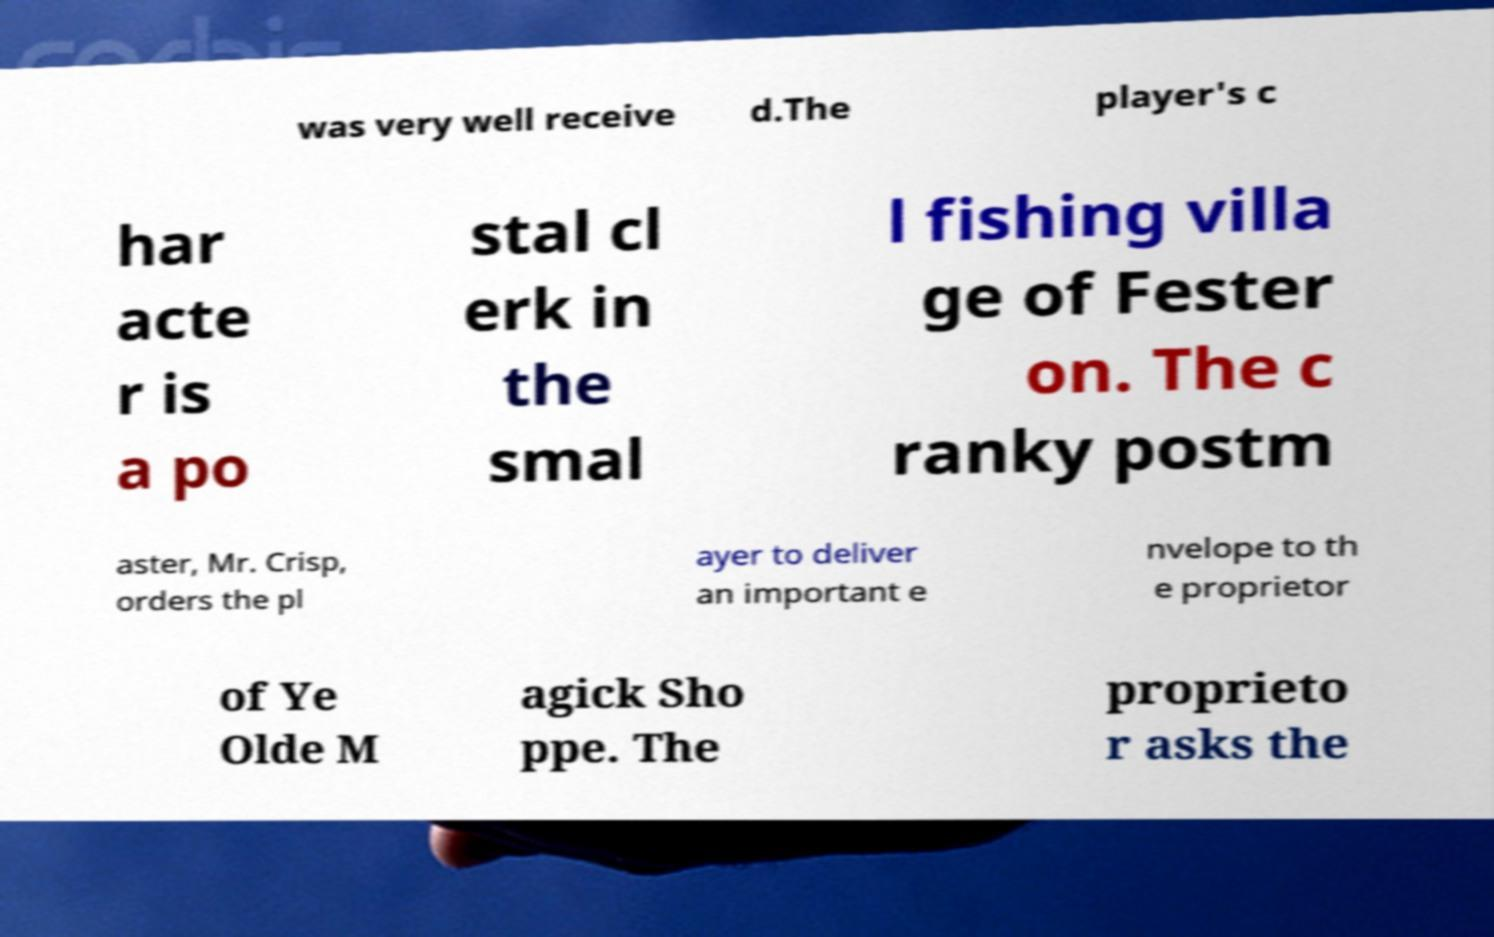For documentation purposes, I need the text within this image transcribed. Could you provide that? was very well receive d.The player's c har acte r is a po stal cl erk in the smal l fishing villa ge of Fester on. The c ranky postm aster, Mr. Crisp, orders the pl ayer to deliver an important e nvelope to th e proprietor of Ye Olde M agick Sho ppe. The proprieto r asks the 